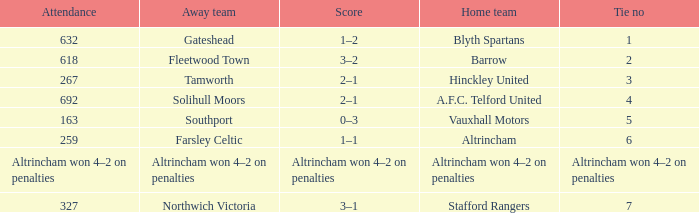Which away side that had a tie with 7 points? Northwich Victoria. 